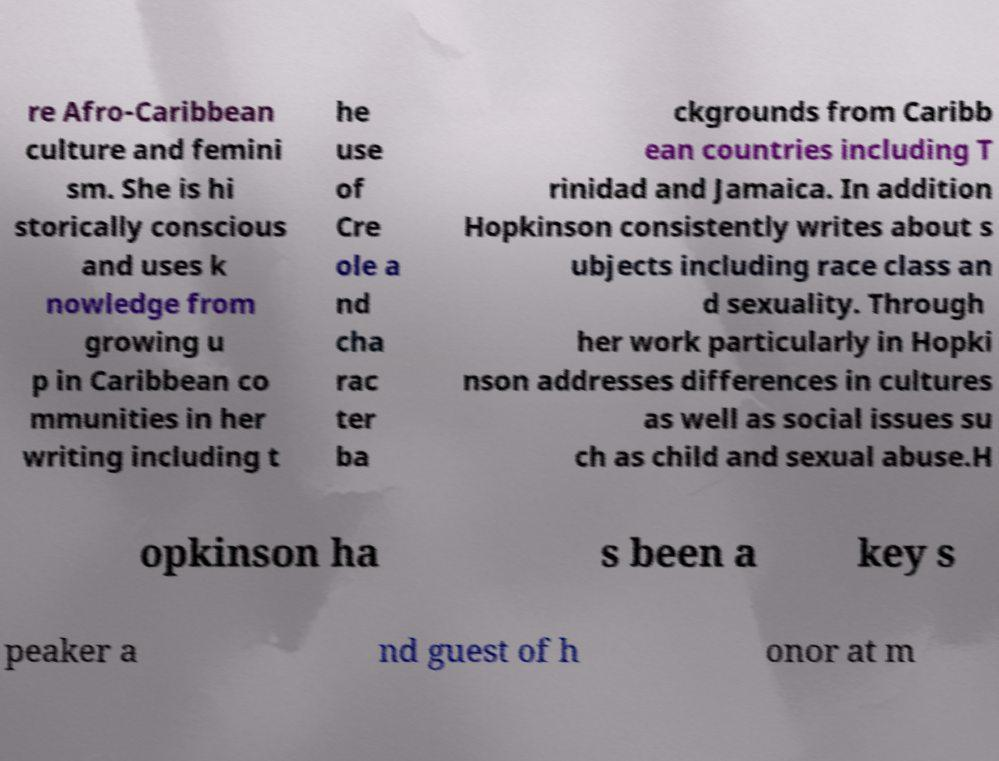Could you extract and type out the text from this image? re Afro-Caribbean culture and femini sm. She is hi storically conscious and uses k nowledge from growing u p in Caribbean co mmunities in her writing including t he use of Cre ole a nd cha rac ter ba ckgrounds from Caribb ean countries including T rinidad and Jamaica. In addition Hopkinson consistently writes about s ubjects including race class an d sexuality. Through her work particularly in Hopki nson addresses differences in cultures as well as social issues su ch as child and sexual abuse.H opkinson ha s been a key s peaker a nd guest of h onor at m 